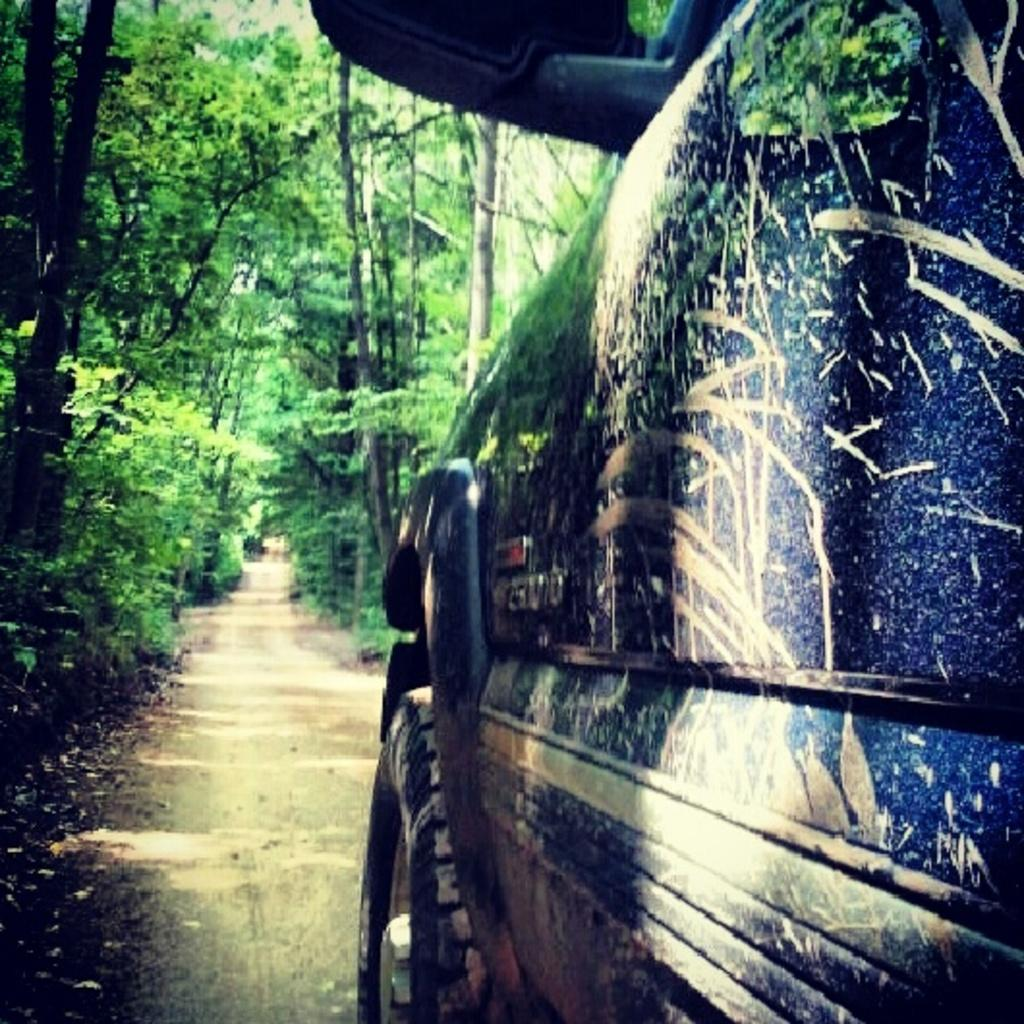What is the main subject in the image? There is a vehicle in the image. What can be seen in the background of the image? There are trees in the background of the image. What is the color of the trees in the image? The trees are green in color. Can you see a cook preparing a meal in the image? There is no cook or meal preparation visible in the image. Is there a chain connecting the vehicle to the trees in the image? There is no chain connecting the vehicle to the trees in the image. 